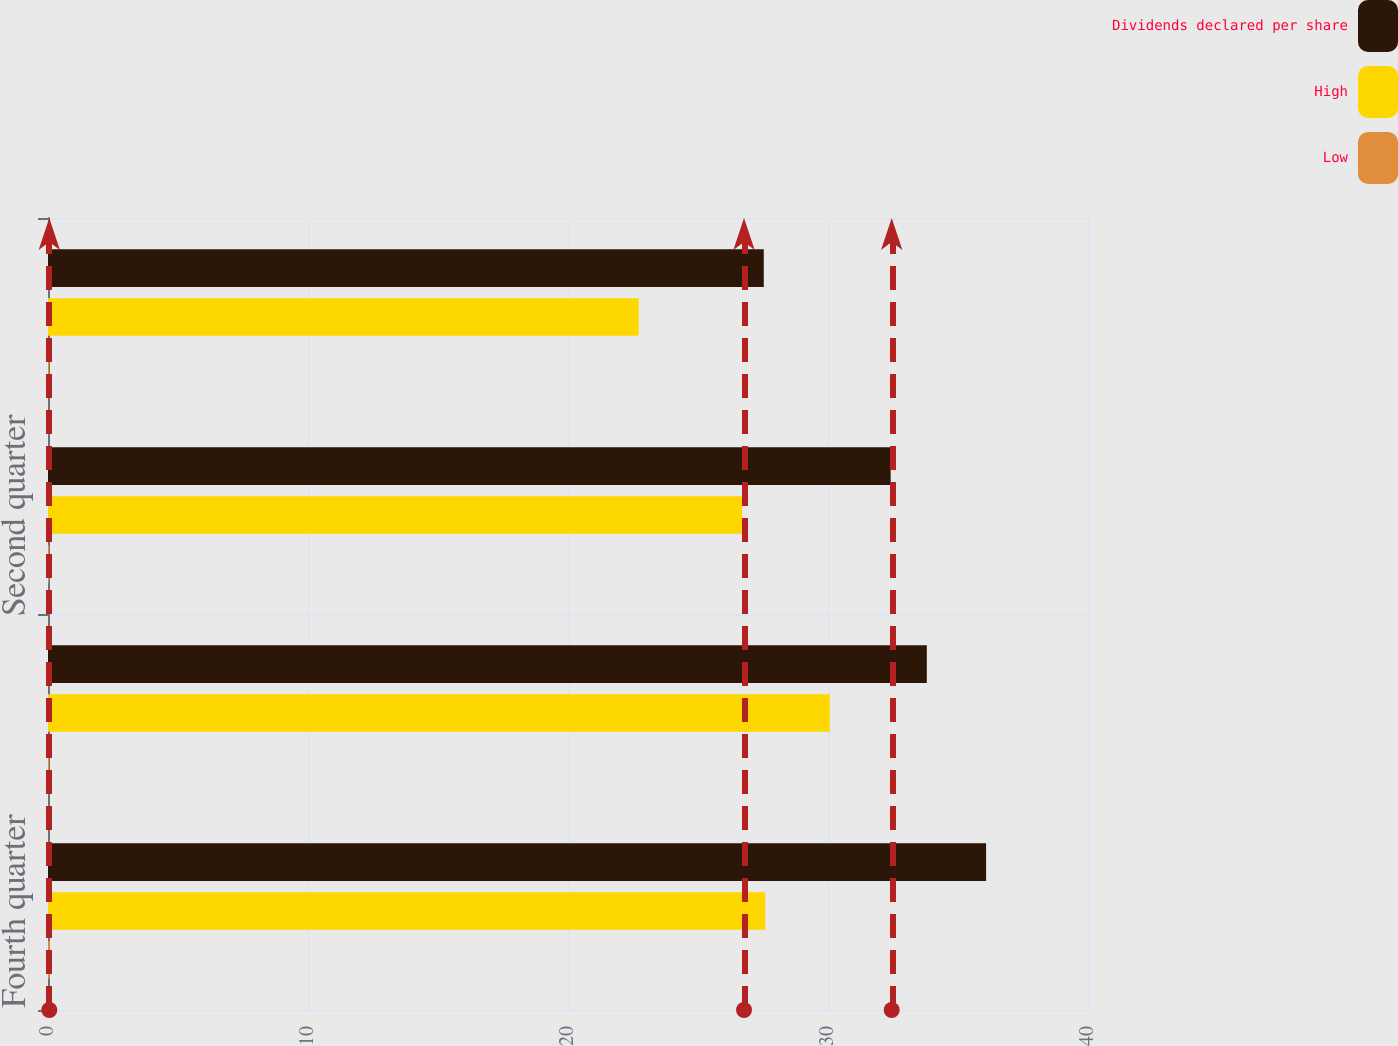Convert chart. <chart><loc_0><loc_0><loc_500><loc_500><stacked_bar_chart><ecel><fcel>Fourth quarter<fcel>Third quarter<fcel>Second quarter<fcel>First quarter<nl><fcel>Dividends declared per share<fcel>36.08<fcel>33.8<fcel>32.41<fcel>27.53<nl><fcel>High<fcel>27.59<fcel>30.07<fcel>26.7<fcel>22.72<nl><fcel>Low<fcel>0.07<fcel>0.04<fcel>0.04<fcel>0.04<nl></chart> 